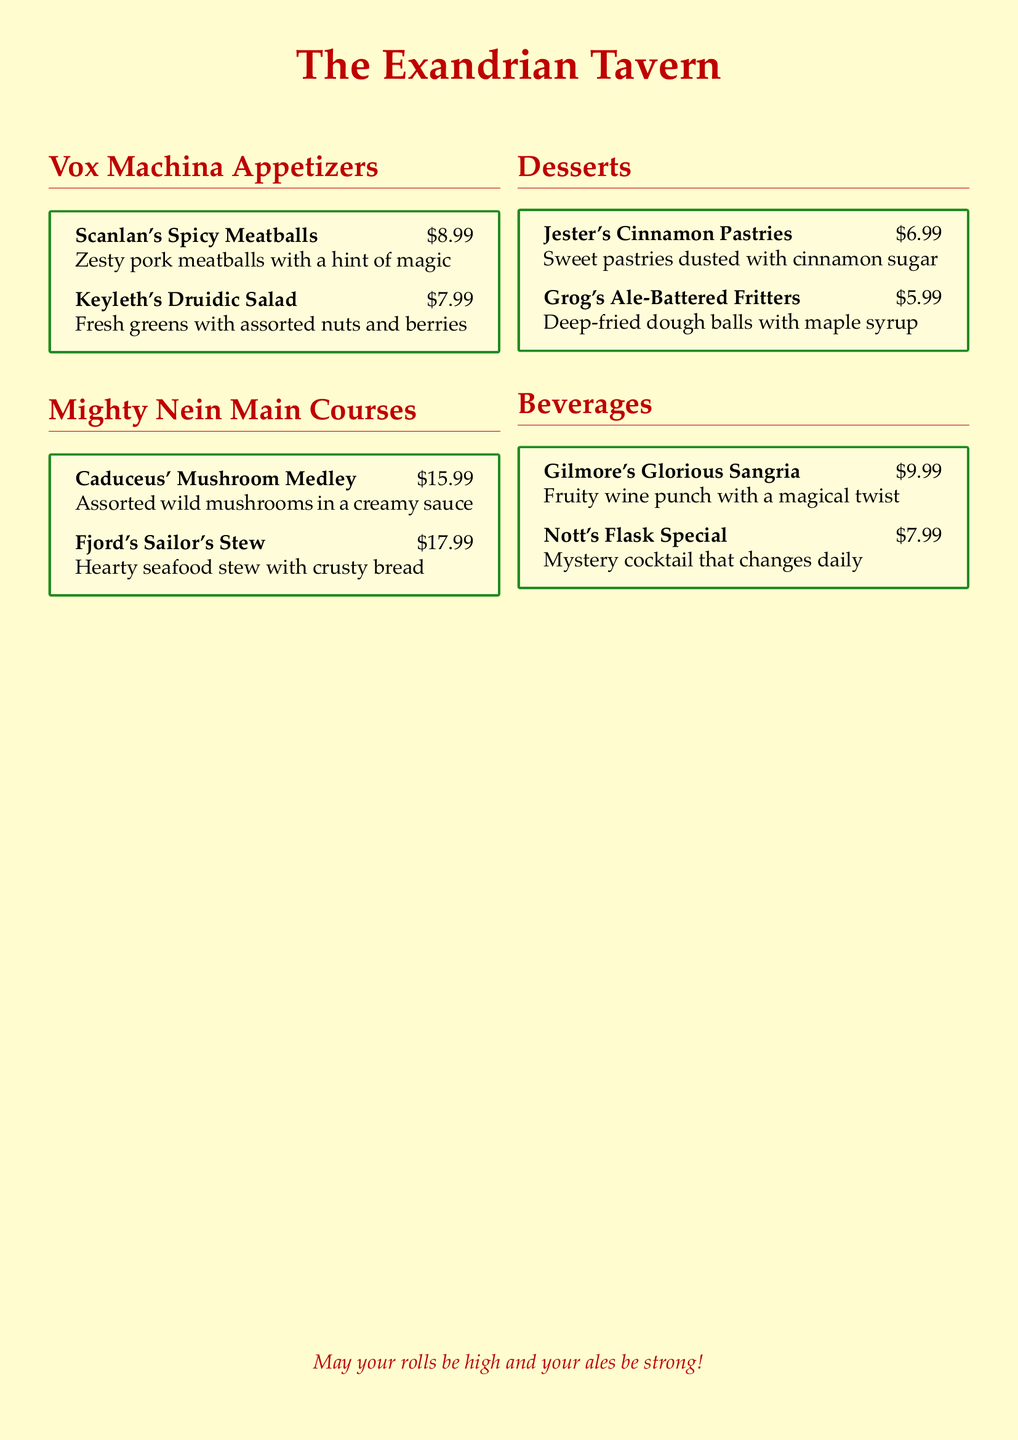what is the name of the first appetizer? The first appetizer listed under Vox Machina Appetizers is Scanlan's Spicy Meatballs.
Answer: Scanlan's Spicy Meatballs how much does Caduceus' Mushroom Medley cost? The cost for Caduceus' Mushroom Medley is provided in the document as $15.99.
Answer: $15.99 which beverage is described as a "mystery cocktail that changes daily"? This description is associated with Nott's Flask Special in the Beverages section.
Answer: Nott's Flask Special what type of dish is Fjord's Sailor's Stew? Fjord's Sailor's Stew is specified as a hearty seafood stew.
Answer: seafood stew how many desserts are listed on the menu? The menu includes two desserts, which are Jester's Cinnamon Pastries and Grog's Ale-Battered Fritters.
Answer: two which character is associated with the "Zesty pork meatballs"? The character associated with the Zesty pork meatballs is Scanlan.
Answer: Scanlan what color is the framing used around the dish descriptions? The color of the framing used around the dish descriptions is forest green.
Answer: forest green what is written in the footer of the document? The footer of the document contains the phrase "May your rolls be high and your ales be strong!"
Answer: May your rolls be high and your ales be strong! 